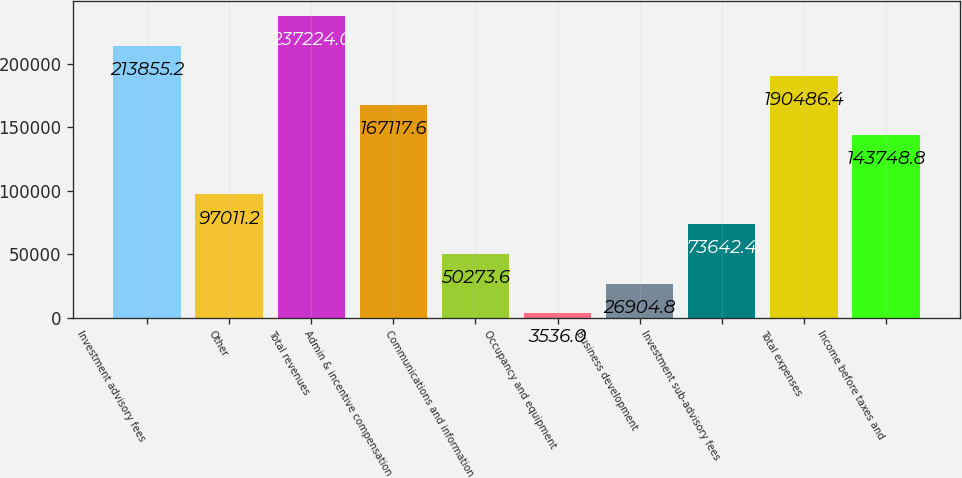<chart> <loc_0><loc_0><loc_500><loc_500><bar_chart><fcel>Investment advisory fees<fcel>Other<fcel>Total revenues<fcel>Admin & incentive compensation<fcel>Communications and information<fcel>Occupancy and equipment<fcel>Business development<fcel>Investment sub-advisory fees<fcel>Total expenses<fcel>Income before taxes and<nl><fcel>213855<fcel>97011.2<fcel>237224<fcel>167118<fcel>50273.6<fcel>3536<fcel>26904.8<fcel>73642.4<fcel>190486<fcel>143749<nl></chart> 